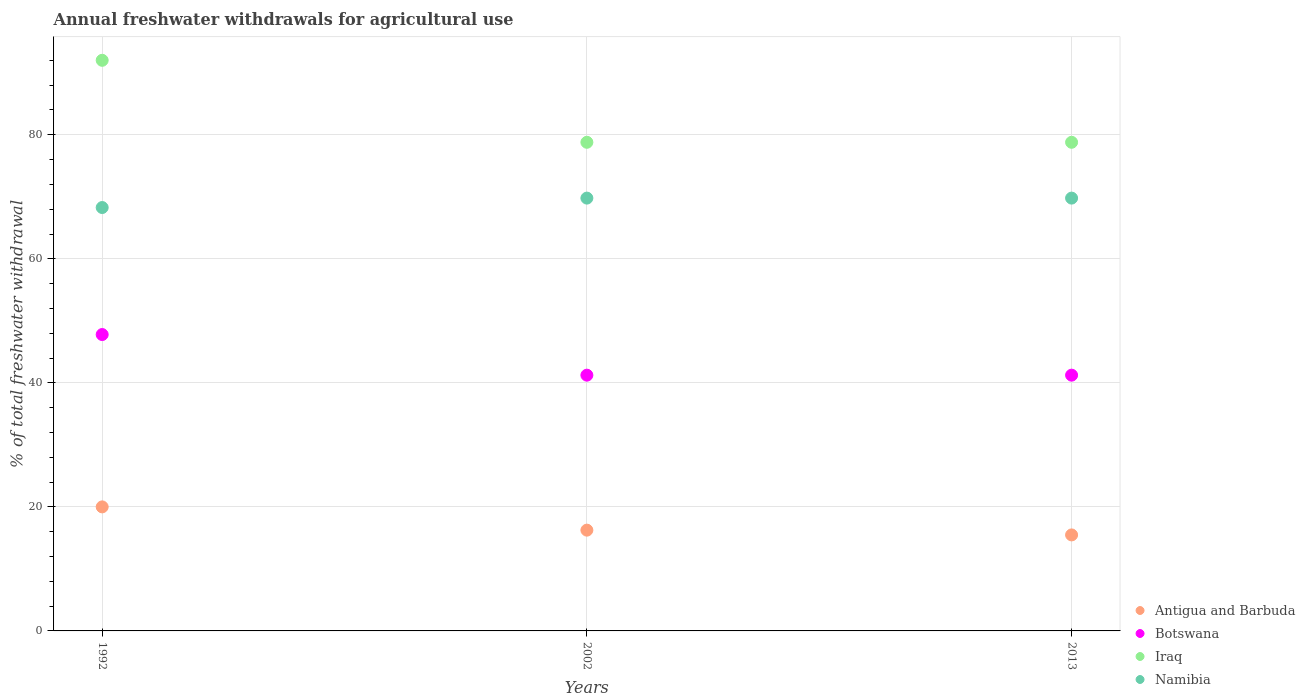Is the number of dotlines equal to the number of legend labels?
Offer a terse response. Yes. What is the total annual withdrawals from freshwater in Antigua and Barbuda in 2002?
Keep it short and to the point. 16.25. Across all years, what is the maximum total annual withdrawals from freshwater in Antigua and Barbuda?
Give a very brief answer. 20. Across all years, what is the minimum total annual withdrawals from freshwater in Iraq?
Offer a terse response. 78.79. In which year was the total annual withdrawals from freshwater in Botswana maximum?
Make the answer very short. 1992. What is the total total annual withdrawals from freshwater in Namibia in the graph?
Provide a succinct answer. 207.85. What is the difference between the total annual withdrawals from freshwater in Antigua and Barbuda in 2002 and the total annual withdrawals from freshwater in Iraq in 1992?
Provide a short and direct response. -75.76. What is the average total annual withdrawals from freshwater in Iraq per year?
Provide a short and direct response. 83.2. In the year 2002, what is the difference between the total annual withdrawals from freshwater in Antigua and Barbuda and total annual withdrawals from freshwater in Iraq?
Your answer should be compact. -62.54. In how many years, is the total annual withdrawals from freshwater in Antigua and Barbuda greater than 12 %?
Your answer should be compact. 3. What is the ratio of the total annual withdrawals from freshwater in Botswana in 1992 to that in 2002?
Offer a very short reply. 1.16. Is the difference between the total annual withdrawals from freshwater in Antigua and Barbuda in 1992 and 2013 greater than the difference between the total annual withdrawals from freshwater in Iraq in 1992 and 2013?
Ensure brevity in your answer.  No. What is the difference between the highest and the second highest total annual withdrawals from freshwater in Namibia?
Your answer should be very brief. 0. What is the difference between the highest and the lowest total annual withdrawals from freshwater in Iraq?
Give a very brief answer. 13.22. In how many years, is the total annual withdrawals from freshwater in Botswana greater than the average total annual withdrawals from freshwater in Botswana taken over all years?
Ensure brevity in your answer.  1. Does the total annual withdrawals from freshwater in Botswana monotonically increase over the years?
Ensure brevity in your answer.  No. How many dotlines are there?
Offer a very short reply. 4. How many years are there in the graph?
Keep it short and to the point. 3. What is the difference between two consecutive major ticks on the Y-axis?
Ensure brevity in your answer.  20. Are the values on the major ticks of Y-axis written in scientific E-notation?
Ensure brevity in your answer.  No. Where does the legend appear in the graph?
Offer a terse response. Bottom right. How are the legend labels stacked?
Ensure brevity in your answer.  Vertical. What is the title of the graph?
Offer a terse response. Annual freshwater withdrawals for agricultural use. What is the label or title of the Y-axis?
Offer a terse response. % of total freshwater withdrawal. What is the % of total freshwater withdrawal of Antigua and Barbuda in 1992?
Your answer should be very brief. 20. What is the % of total freshwater withdrawal of Botswana in 1992?
Keep it short and to the point. 47.79. What is the % of total freshwater withdrawal of Iraq in 1992?
Your answer should be compact. 92.01. What is the % of total freshwater withdrawal in Namibia in 1992?
Give a very brief answer. 68.27. What is the % of total freshwater withdrawal in Antigua and Barbuda in 2002?
Provide a succinct answer. 16.25. What is the % of total freshwater withdrawal in Botswana in 2002?
Provide a succinct answer. 41.24. What is the % of total freshwater withdrawal of Iraq in 2002?
Make the answer very short. 78.79. What is the % of total freshwater withdrawal in Namibia in 2002?
Offer a terse response. 69.79. What is the % of total freshwater withdrawal of Antigua and Barbuda in 2013?
Offer a very short reply. 15.48. What is the % of total freshwater withdrawal in Botswana in 2013?
Give a very brief answer. 41.24. What is the % of total freshwater withdrawal of Iraq in 2013?
Offer a very short reply. 78.79. What is the % of total freshwater withdrawal of Namibia in 2013?
Provide a succinct answer. 69.79. Across all years, what is the maximum % of total freshwater withdrawal of Antigua and Barbuda?
Offer a terse response. 20. Across all years, what is the maximum % of total freshwater withdrawal in Botswana?
Ensure brevity in your answer.  47.79. Across all years, what is the maximum % of total freshwater withdrawal in Iraq?
Offer a terse response. 92.01. Across all years, what is the maximum % of total freshwater withdrawal in Namibia?
Give a very brief answer. 69.79. Across all years, what is the minimum % of total freshwater withdrawal of Antigua and Barbuda?
Ensure brevity in your answer.  15.48. Across all years, what is the minimum % of total freshwater withdrawal in Botswana?
Keep it short and to the point. 41.24. Across all years, what is the minimum % of total freshwater withdrawal in Iraq?
Offer a terse response. 78.79. Across all years, what is the minimum % of total freshwater withdrawal of Namibia?
Give a very brief answer. 68.27. What is the total % of total freshwater withdrawal of Antigua and Barbuda in the graph?
Your answer should be compact. 51.73. What is the total % of total freshwater withdrawal in Botswana in the graph?
Make the answer very short. 130.27. What is the total % of total freshwater withdrawal in Iraq in the graph?
Provide a short and direct response. 249.59. What is the total % of total freshwater withdrawal of Namibia in the graph?
Offer a terse response. 207.85. What is the difference between the % of total freshwater withdrawal of Antigua and Barbuda in 1992 and that in 2002?
Ensure brevity in your answer.  3.75. What is the difference between the % of total freshwater withdrawal in Botswana in 1992 and that in 2002?
Offer a very short reply. 6.55. What is the difference between the % of total freshwater withdrawal of Iraq in 1992 and that in 2002?
Offer a very short reply. 13.22. What is the difference between the % of total freshwater withdrawal in Namibia in 1992 and that in 2002?
Give a very brief answer. -1.52. What is the difference between the % of total freshwater withdrawal of Antigua and Barbuda in 1992 and that in 2013?
Your answer should be very brief. 4.52. What is the difference between the % of total freshwater withdrawal of Botswana in 1992 and that in 2013?
Offer a terse response. 6.55. What is the difference between the % of total freshwater withdrawal in Iraq in 1992 and that in 2013?
Your answer should be compact. 13.22. What is the difference between the % of total freshwater withdrawal of Namibia in 1992 and that in 2013?
Your answer should be compact. -1.52. What is the difference between the % of total freshwater withdrawal in Antigua and Barbuda in 2002 and that in 2013?
Offer a very short reply. 0.77. What is the difference between the % of total freshwater withdrawal of Botswana in 2002 and that in 2013?
Make the answer very short. 0. What is the difference between the % of total freshwater withdrawal in Iraq in 2002 and that in 2013?
Your answer should be very brief. 0. What is the difference between the % of total freshwater withdrawal of Antigua and Barbuda in 1992 and the % of total freshwater withdrawal of Botswana in 2002?
Offer a very short reply. -21.24. What is the difference between the % of total freshwater withdrawal in Antigua and Barbuda in 1992 and the % of total freshwater withdrawal in Iraq in 2002?
Ensure brevity in your answer.  -58.79. What is the difference between the % of total freshwater withdrawal of Antigua and Barbuda in 1992 and the % of total freshwater withdrawal of Namibia in 2002?
Keep it short and to the point. -49.79. What is the difference between the % of total freshwater withdrawal in Botswana in 1992 and the % of total freshwater withdrawal in Iraq in 2002?
Your answer should be compact. -31. What is the difference between the % of total freshwater withdrawal of Botswana in 1992 and the % of total freshwater withdrawal of Namibia in 2002?
Provide a succinct answer. -22. What is the difference between the % of total freshwater withdrawal in Iraq in 1992 and the % of total freshwater withdrawal in Namibia in 2002?
Give a very brief answer. 22.22. What is the difference between the % of total freshwater withdrawal in Antigua and Barbuda in 1992 and the % of total freshwater withdrawal in Botswana in 2013?
Ensure brevity in your answer.  -21.24. What is the difference between the % of total freshwater withdrawal of Antigua and Barbuda in 1992 and the % of total freshwater withdrawal of Iraq in 2013?
Give a very brief answer. -58.79. What is the difference between the % of total freshwater withdrawal of Antigua and Barbuda in 1992 and the % of total freshwater withdrawal of Namibia in 2013?
Your response must be concise. -49.79. What is the difference between the % of total freshwater withdrawal of Botswana in 1992 and the % of total freshwater withdrawal of Iraq in 2013?
Provide a succinct answer. -31. What is the difference between the % of total freshwater withdrawal in Botswana in 1992 and the % of total freshwater withdrawal in Namibia in 2013?
Offer a terse response. -22. What is the difference between the % of total freshwater withdrawal in Iraq in 1992 and the % of total freshwater withdrawal in Namibia in 2013?
Your answer should be very brief. 22.22. What is the difference between the % of total freshwater withdrawal in Antigua and Barbuda in 2002 and the % of total freshwater withdrawal in Botswana in 2013?
Offer a terse response. -24.99. What is the difference between the % of total freshwater withdrawal in Antigua and Barbuda in 2002 and the % of total freshwater withdrawal in Iraq in 2013?
Make the answer very short. -62.54. What is the difference between the % of total freshwater withdrawal of Antigua and Barbuda in 2002 and the % of total freshwater withdrawal of Namibia in 2013?
Keep it short and to the point. -53.54. What is the difference between the % of total freshwater withdrawal in Botswana in 2002 and the % of total freshwater withdrawal in Iraq in 2013?
Ensure brevity in your answer.  -37.55. What is the difference between the % of total freshwater withdrawal in Botswana in 2002 and the % of total freshwater withdrawal in Namibia in 2013?
Offer a terse response. -28.55. What is the difference between the % of total freshwater withdrawal of Iraq in 2002 and the % of total freshwater withdrawal of Namibia in 2013?
Ensure brevity in your answer.  9. What is the average % of total freshwater withdrawal of Antigua and Barbuda per year?
Your answer should be compact. 17.24. What is the average % of total freshwater withdrawal of Botswana per year?
Make the answer very short. 43.42. What is the average % of total freshwater withdrawal of Iraq per year?
Your answer should be very brief. 83.2. What is the average % of total freshwater withdrawal in Namibia per year?
Provide a short and direct response. 69.28. In the year 1992, what is the difference between the % of total freshwater withdrawal of Antigua and Barbuda and % of total freshwater withdrawal of Botswana?
Offer a terse response. -27.79. In the year 1992, what is the difference between the % of total freshwater withdrawal of Antigua and Barbuda and % of total freshwater withdrawal of Iraq?
Make the answer very short. -72.01. In the year 1992, what is the difference between the % of total freshwater withdrawal of Antigua and Barbuda and % of total freshwater withdrawal of Namibia?
Give a very brief answer. -48.27. In the year 1992, what is the difference between the % of total freshwater withdrawal of Botswana and % of total freshwater withdrawal of Iraq?
Offer a terse response. -44.22. In the year 1992, what is the difference between the % of total freshwater withdrawal of Botswana and % of total freshwater withdrawal of Namibia?
Offer a very short reply. -20.48. In the year 1992, what is the difference between the % of total freshwater withdrawal in Iraq and % of total freshwater withdrawal in Namibia?
Offer a very short reply. 23.74. In the year 2002, what is the difference between the % of total freshwater withdrawal in Antigua and Barbuda and % of total freshwater withdrawal in Botswana?
Make the answer very short. -24.99. In the year 2002, what is the difference between the % of total freshwater withdrawal of Antigua and Barbuda and % of total freshwater withdrawal of Iraq?
Keep it short and to the point. -62.54. In the year 2002, what is the difference between the % of total freshwater withdrawal of Antigua and Barbuda and % of total freshwater withdrawal of Namibia?
Your response must be concise. -53.54. In the year 2002, what is the difference between the % of total freshwater withdrawal of Botswana and % of total freshwater withdrawal of Iraq?
Your answer should be very brief. -37.55. In the year 2002, what is the difference between the % of total freshwater withdrawal of Botswana and % of total freshwater withdrawal of Namibia?
Keep it short and to the point. -28.55. In the year 2013, what is the difference between the % of total freshwater withdrawal in Antigua and Barbuda and % of total freshwater withdrawal in Botswana?
Your answer should be compact. -25.76. In the year 2013, what is the difference between the % of total freshwater withdrawal in Antigua and Barbuda and % of total freshwater withdrawal in Iraq?
Your response must be concise. -63.31. In the year 2013, what is the difference between the % of total freshwater withdrawal in Antigua and Barbuda and % of total freshwater withdrawal in Namibia?
Ensure brevity in your answer.  -54.31. In the year 2013, what is the difference between the % of total freshwater withdrawal of Botswana and % of total freshwater withdrawal of Iraq?
Make the answer very short. -37.55. In the year 2013, what is the difference between the % of total freshwater withdrawal of Botswana and % of total freshwater withdrawal of Namibia?
Make the answer very short. -28.55. In the year 2013, what is the difference between the % of total freshwater withdrawal of Iraq and % of total freshwater withdrawal of Namibia?
Provide a short and direct response. 9. What is the ratio of the % of total freshwater withdrawal in Antigua and Barbuda in 1992 to that in 2002?
Your answer should be compact. 1.23. What is the ratio of the % of total freshwater withdrawal of Botswana in 1992 to that in 2002?
Ensure brevity in your answer.  1.16. What is the ratio of the % of total freshwater withdrawal in Iraq in 1992 to that in 2002?
Offer a terse response. 1.17. What is the ratio of the % of total freshwater withdrawal in Namibia in 1992 to that in 2002?
Your response must be concise. 0.98. What is the ratio of the % of total freshwater withdrawal in Antigua and Barbuda in 1992 to that in 2013?
Ensure brevity in your answer.  1.29. What is the ratio of the % of total freshwater withdrawal of Botswana in 1992 to that in 2013?
Provide a succinct answer. 1.16. What is the ratio of the % of total freshwater withdrawal of Iraq in 1992 to that in 2013?
Provide a succinct answer. 1.17. What is the ratio of the % of total freshwater withdrawal in Namibia in 1992 to that in 2013?
Offer a terse response. 0.98. What is the ratio of the % of total freshwater withdrawal in Antigua and Barbuda in 2002 to that in 2013?
Provide a succinct answer. 1.05. What is the ratio of the % of total freshwater withdrawal in Botswana in 2002 to that in 2013?
Your response must be concise. 1. What is the ratio of the % of total freshwater withdrawal in Iraq in 2002 to that in 2013?
Make the answer very short. 1. What is the ratio of the % of total freshwater withdrawal in Namibia in 2002 to that in 2013?
Your answer should be compact. 1. What is the difference between the highest and the second highest % of total freshwater withdrawal in Antigua and Barbuda?
Give a very brief answer. 3.75. What is the difference between the highest and the second highest % of total freshwater withdrawal in Botswana?
Provide a succinct answer. 6.55. What is the difference between the highest and the second highest % of total freshwater withdrawal in Iraq?
Make the answer very short. 13.22. What is the difference between the highest and the second highest % of total freshwater withdrawal in Namibia?
Give a very brief answer. 0. What is the difference between the highest and the lowest % of total freshwater withdrawal of Antigua and Barbuda?
Provide a succinct answer. 4.52. What is the difference between the highest and the lowest % of total freshwater withdrawal in Botswana?
Provide a short and direct response. 6.55. What is the difference between the highest and the lowest % of total freshwater withdrawal in Iraq?
Ensure brevity in your answer.  13.22. What is the difference between the highest and the lowest % of total freshwater withdrawal of Namibia?
Provide a short and direct response. 1.52. 